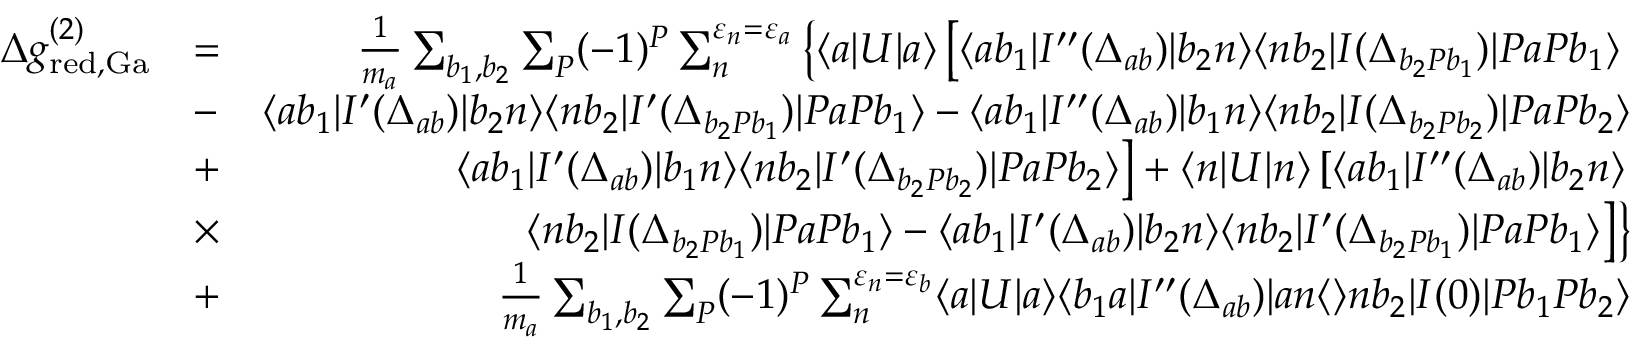Convert formula to latex. <formula><loc_0><loc_0><loc_500><loc_500>\begin{array} { r l r } { \Delta g _ { r e d , G a } ^ { ( 2 ) } } & { = } & { \frac { 1 } { m _ { a } } \sum _ { b _ { 1 } , b _ { 2 } } \sum _ { P } ( - 1 ) ^ { P } \sum _ { n } ^ { \varepsilon _ { n } = \varepsilon _ { a } } \left \{ \langle a | U | a \rangle \left [ \langle a b _ { 1 } | I ^ { \prime \prime } ( \Delta _ { a b } ) | b _ { 2 } n \rangle \langle n b _ { 2 } | I ( \Delta _ { b _ { 2 } P b _ { 1 } } ) | P a P b _ { 1 } \rangle } \\ & { - } & { \langle a b _ { 1 } | I ^ { \prime } ( \Delta _ { a b } ) | b _ { 2 } n \rangle \langle n b _ { 2 } | I ^ { \prime } ( \Delta _ { b _ { 2 } P b _ { 1 } } ) | P a P b _ { 1 } \rangle - \langle a b _ { 1 } | I ^ { \prime \prime } ( \Delta _ { a b } ) | b _ { 1 } n \rangle \langle n b _ { 2 } | I ( \Delta _ { b _ { 2 } P b _ { 2 } } ) | P a P b _ { 2 } \rangle } \\ & { + } & { \langle a b _ { 1 } | I ^ { \prime } ( \Delta _ { a b } ) | b _ { 1 } n \rangle \langle n b _ { 2 } | I ^ { \prime } ( \Delta _ { b _ { 2 } P b _ { 2 } } ) | P a P b _ { 2 } \rangle \right ] + \langle n | U | n \rangle \left [ \langle a b _ { 1 } | I ^ { \prime \prime } ( \Delta _ { a b } ) | b _ { 2 } n \rangle } \\ & { \times } & { \langle n b _ { 2 } | I ( \Delta _ { b _ { 2 } P b _ { 1 } } ) | P a P b _ { 1 } \rangle - \langle a b _ { 1 } | I ^ { \prime } ( \Delta _ { a b } ) | b _ { 2 } n \rangle \langle n b _ { 2 } | I ^ { \prime } ( \Delta _ { b _ { 2 } P b _ { 1 } } ) | P a P b _ { 1 } \rangle \right ] \right \} } \\ & { + } & { \frac { 1 } { m _ { a } } \sum _ { b _ { 1 } , b _ { 2 } } \sum _ { P } ( - 1 ) ^ { P } \sum _ { n } ^ { \varepsilon _ { n } = \varepsilon _ { b } } \langle a | U | a \rangle \langle b _ { 1 } a | I ^ { \prime \prime } ( \Delta _ { a b } ) | a n \langle \rangle n b _ { 2 } | I ( 0 ) | P b _ { 1 } P b _ { 2 } \rangle } \end{array}</formula> 